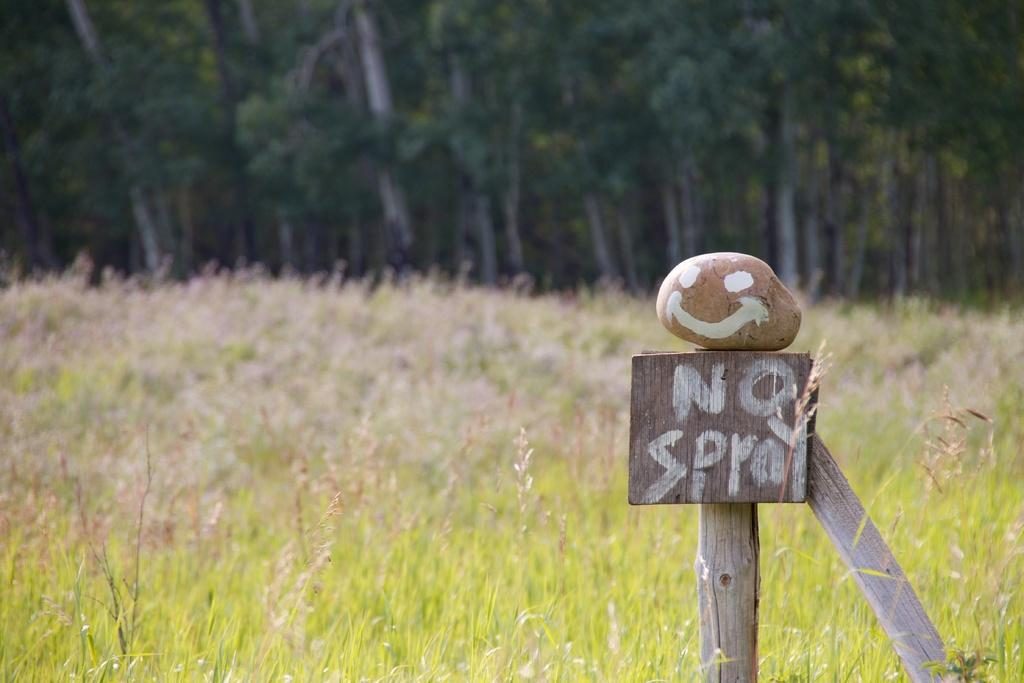What is the main object in the image that has paint on it? There is a stone with paint in the image. What is written or depicted on the wooden board in the image? There is text on a wooden board in the image. How is the wooden board supported in the image? The wooden board is supported by two wooden sticks in the image. What type of natural environment is visible in the image? There is grass visible in the image, and trees are in the background. What type of thrill can be experienced by the stone in the image? The stone in the image is not capable of experiencing any emotions or thrills, as it is an inanimate object. 